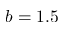Convert formula to latex. <formula><loc_0><loc_0><loc_500><loc_500>b = 1 . 5</formula> 